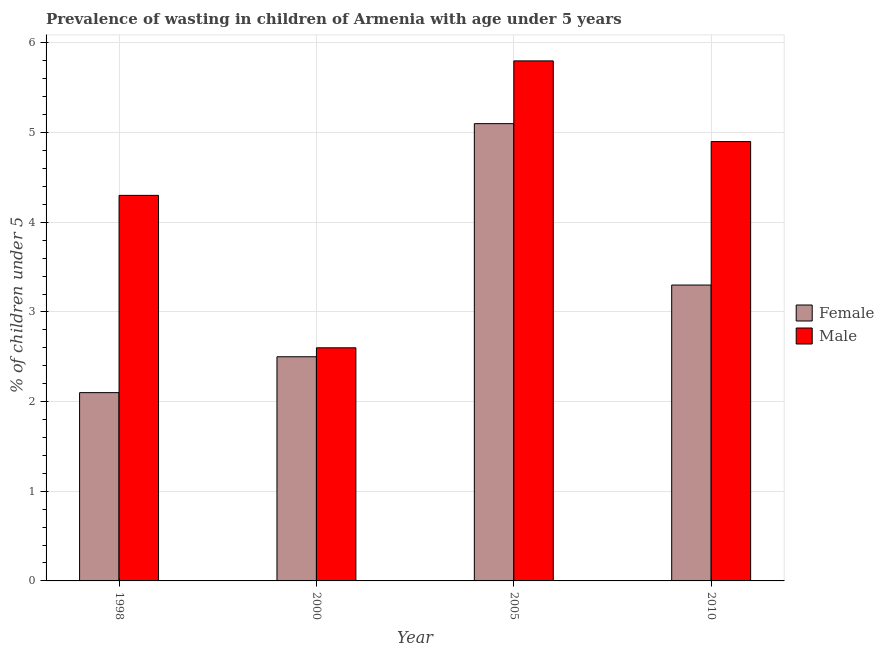How many groups of bars are there?
Offer a very short reply. 4. Are the number of bars per tick equal to the number of legend labels?
Offer a terse response. Yes. Are the number of bars on each tick of the X-axis equal?
Ensure brevity in your answer.  Yes. How many bars are there on the 1st tick from the left?
Your answer should be very brief. 2. What is the label of the 2nd group of bars from the left?
Offer a very short reply. 2000. In how many cases, is the number of bars for a given year not equal to the number of legend labels?
Make the answer very short. 0. What is the percentage of undernourished male children in 1998?
Offer a terse response. 4.3. Across all years, what is the maximum percentage of undernourished male children?
Provide a short and direct response. 5.8. Across all years, what is the minimum percentage of undernourished male children?
Provide a succinct answer. 2.6. In which year was the percentage of undernourished female children maximum?
Your response must be concise. 2005. In which year was the percentage of undernourished female children minimum?
Make the answer very short. 1998. What is the total percentage of undernourished male children in the graph?
Ensure brevity in your answer.  17.6. What is the difference between the percentage of undernourished male children in 1998 and that in 2010?
Offer a terse response. -0.6. What is the difference between the percentage of undernourished male children in 1998 and the percentage of undernourished female children in 2000?
Provide a short and direct response. 1.7. What is the average percentage of undernourished male children per year?
Ensure brevity in your answer.  4.4. In how many years, is the percentage of undernourished male children greater than 2.4 %?
Give a very brief answer. 4. What is the ratio of the percentage of undernourished female children in 1998 to that in 2005?
Offer a very short reply. 0.41. Is the percentage of undernourished female children in 1998 less than that in 2010?
Make the answer very short. Yes. What is the difference between the highest and the second highest percentage of undernourished female children?
Ensure brevity in your answer.  1.8. What is the difference between the highest and the lowest percentage of undernourished male children?
Offer a terse response. 3.2. In how many years, is the percentage of undernourished female children greater than the average percentage of undernourished female children taken over all years?
Give a very brief answer. 2. Is the sum of the percentage of undernourished female children in 1998 and 2000 greater than the maximum percentage of undernourished male children across all years?
Ensure brevity in your answer.  No. What does the 1st bar from the left in 2010 represents?
Provide a short and direct response. Female. What does the 2nd bar from the right in 2000 represents?
Your answer should be compact. Female. How many years are there in the graph?
Your answer should be compact. 4. Are the values on the major ticks of Y-axis written in scientific E-notation?
Your answer should be compact. No. Does the graph contain any zero values?
Your answer should be very brief. No. Does the graph contain grids?
Make the answer very short. Yes. How many legend labels are there?
Your answer should be very brief. 2. What is the title of the graph?
Ensure brevity in your answer.  Prevalence of wasting in children of Armenia with age under 5 years. Does "Export" appear as one of the legend labels in the graph?
Provide a short and direct response. No. What is the label or title of the X-axis?
Your response must be concise. Year. What is the label or title of the Y-axis?
Your answer should be compact.  % of children under 5. What is the  % of children under 5 of Female in 1998?
Your answer should be compact. 2.1. What is the  % of children under 5 of Male in 1998?
Provide a short and direct response. 4.3. What is the  % of children under 5 of Male in 2000?
Give a very brief answer. 2.6. What is the  % of children under 5 of Female in 2005?
Keep it short and to the point. 5.1. What is the  % of children under 5 in Male in 2005?
Give a very brief answer. 5.8. What is the  % of children under 5 in Female in 2010?
Make the answer very short. 3.3. What is the  % of children under 5 of Male in 2010?
Offer a terse response. 4.9. Across all years, what is the maximum  % of children under 5 of Female?
Ensure brevity in your answer.  5.1. Across all years, what is the maximum  % of children under 5 of Male?
Keep it short and to the point. 5.8. Across all years, what is the minimum  % of children under 5 in Female?
Provide a short and direct response. 2.1. Across all years, what is the minimum  % of children under 5 of Male?
Your answer should be compact. 2.6. What is the total  % of children under 5 in Female in the graph?
Provide a short and direct response. 13. What is the total  % of children under 5 of Male in the graph?
Give a very brief answer. 17.6. What is the difference between the  % of children under 5 of Female in 1998 and that in 2000?
Offer a terse response. -0.4. What is the difference between the  % of children under 5 of Male in 1998 and that in 2000?
Your answer should be compact. 1.7. What is the difference between the  % of children under 5 of Female in 1998 and that in 2005?
Offer a terse response. -3. What is the difference between the  % of children under 5 of Male in 1998 and that in 2005?
Make the answer very short. -1.5. What is the difference between the  % of children under 5 of Female in 1998 and that in 2010?
Offer a terse response. -1.2. What is the difference between the  % of children under 5 in Male in 1998 and that in 2010?
Provide a succinct answer. -0.6. What is the difference between the  % of children under 5 of Male in 2000 and that in 2005?
Offer a terse response. -3.2. What is the difference between the  % of children under 5 in Female in 2000 and that in 2010?
Provide a short and direct response. -0.8. What is the difference between the  % of children under 5 of Male in 2000 and that in 2010?
Your response must be concise. -2.3. What is the difference between the  % of children under 5 in Female in 2005 and that in 2010?
Your response must be concise. 1.8. What is the difference between the  % of children under 5 in Male in 2005 and that in 2010?
Make the answer very short. 0.9. What is the difference between the  % of children under 5 in Female in 1998 and the  % of children under 5 in Male in 2005?
Your answer should be compact. -3.7. What is the difference between the  % of children under 5 in Female in 1998 and the  % of children under 5 in Male in 2010?
Ensure brevity in your answer.  -2.8. What is the difference between the  % of children under 5 in Female in 2000 and the  % of children under 5 in Male in 2005?
Make the answer very short. -3.3. What is the difference between the  % of children under 5 of Female in 2005 and the  % of children under 5 of Male in 2010?
Keep it short and to the point. 0.2. What is the average  % of children under 5 of Female per year?
Offer a terse response. 3.25. What is the ratio of the  % of children under 5 in Female in 1998 to that in 2000?
Your answer should be compact. 0.84. What is the ratio of the  % of children under 5 of Male in 1998 to that in 2000?
Offer a terse response. 1.65. What is the ratio of the  % of children under 5 in Female in 1998 to that in 2005?
Your answer should be very brief. 0.41. What is the ratio of the  % of children under 5 of Male in 1998 to that in 2005?
Give a very brief answer. 0.74. What is the ratio of the  % of children under 5 in Female in 1998 to that in 2010?
Your answer should be very brief. 0.64. What is the ratio of the  % of children under 5 of Male in 1998 to that in 2010?
Keep it short and to the point. 0.88. What is the ratio of the  % of children under 5 in Female in 2000 to that in 2005?
Ensure brevity in your answer.  0.49. What is the ratio of the  % of children under 5 in Male in 2000 to that in 2005?
Provide a short and direct response. 0.45. What is the ratio of the  % of children under 5 in Female in 2000 to that in 2010?
Provide a succinct answer. 0.76. What is the ratio of the  % of children under 5 in Male in 2000 to that in 2010?
Offer a terse response. 0.53. What is the ratio of the  % of children under 5 of Female in 2005 to that in 2010?
Your answer should be compact. 1.55. What is the ratio of the  % of children under 5 of Male in 2005 to that in 2010?
Offer a very short reply. 1.18. What is the difference between the highest and the second highest  % of children under 5 in Female?
Offer a terse response. 1.8. What is the difference between the highest and the second highest  % of children under 5 of Male?
Your answer should be compact. 0.9. What is the difference between the highest and the lowest  % of children under 5 in Female?
Provide a succinct answer. 3. What is the difference between the highest and the lowest  % of children under 5 in Male?
Provide a succinct answer. 3.2. 